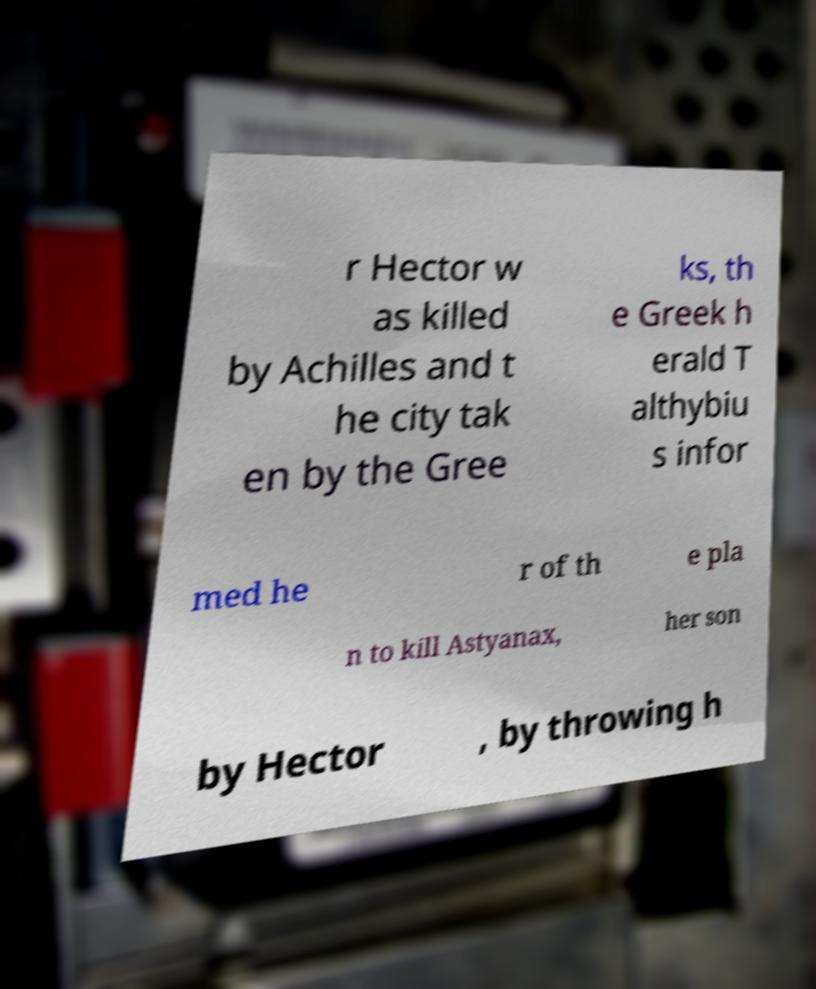For documentation purposes, I need the text within this image transcribed. Could you provide that? r Hector w as killed by Achilles and t he city tak en by the Gree ks, th e Greek h erald T althybiu s infor med he r of th e pla n to kill Astyanax, her son by Hector , by throwing h 